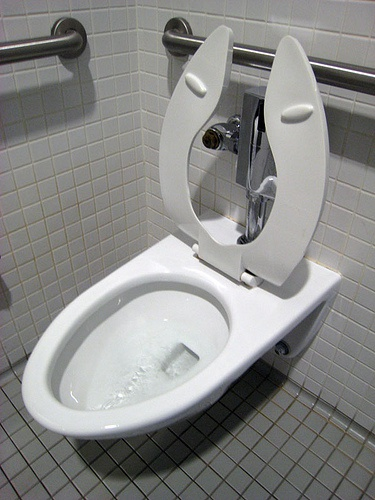Describe the objects in this image and their specific colors. I can see a toilet in gray, lightgray, darkgray, and black tones in this image. 